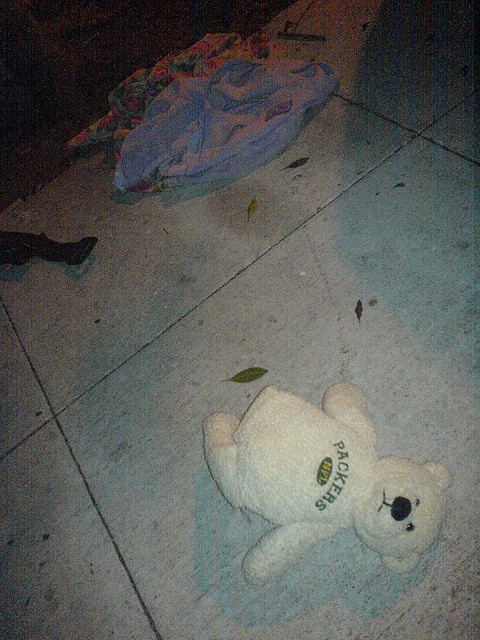Describe the objects in this image and their specific colors. I can see a teddy bear in black, darkgray, and gray tones in this image. 